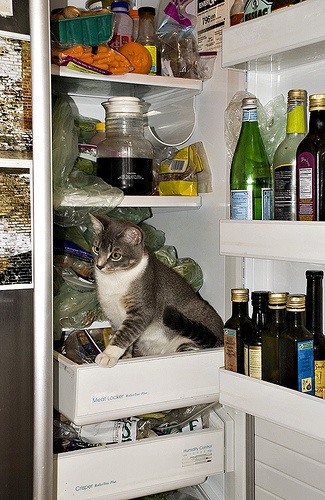Describe the objects in this image and their specific colors. I can see refrigerator in darkgray, lightgray, black, and gray tones, cat in lightgray, black, gray, and darkgray tones, bottle in lightgray, black, gray, and darkgray tones, bottle in lightgray, darkgreen, and black tones, and bottle in lightgray, black, purple, and darkgray tones in this image. 